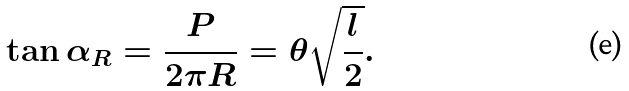<formula> <loc_0><loc_0><loc_500><loc_500>\tan \alpha _ { R } = \frac { P } { 2 \pi R } = \theta \sqrt { \frac { l } { 2 } } .</formula> 